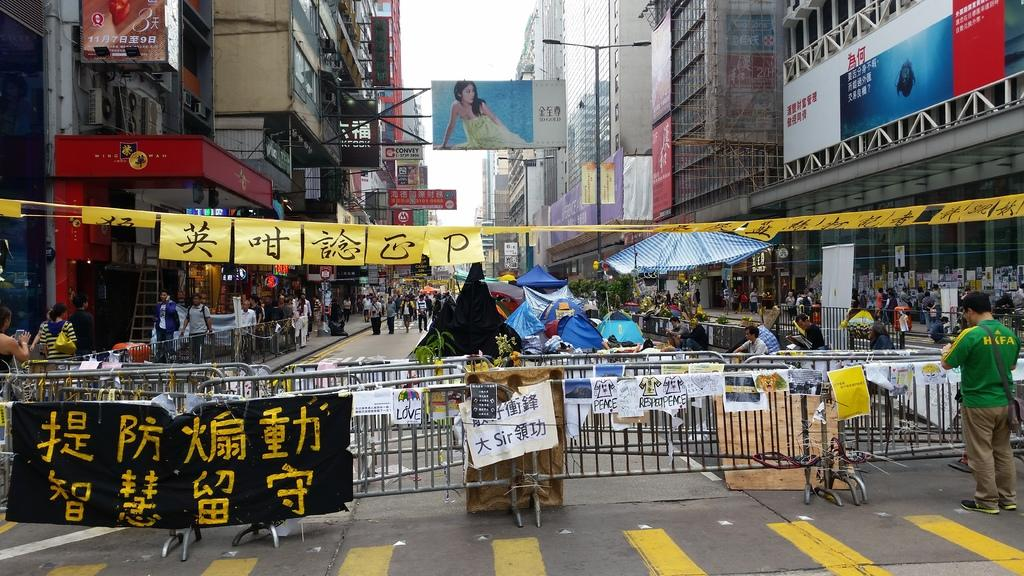<image>
Write a terse but informative summary of the picture. an ad of a lady in a dress with Japanese writing everywhere 